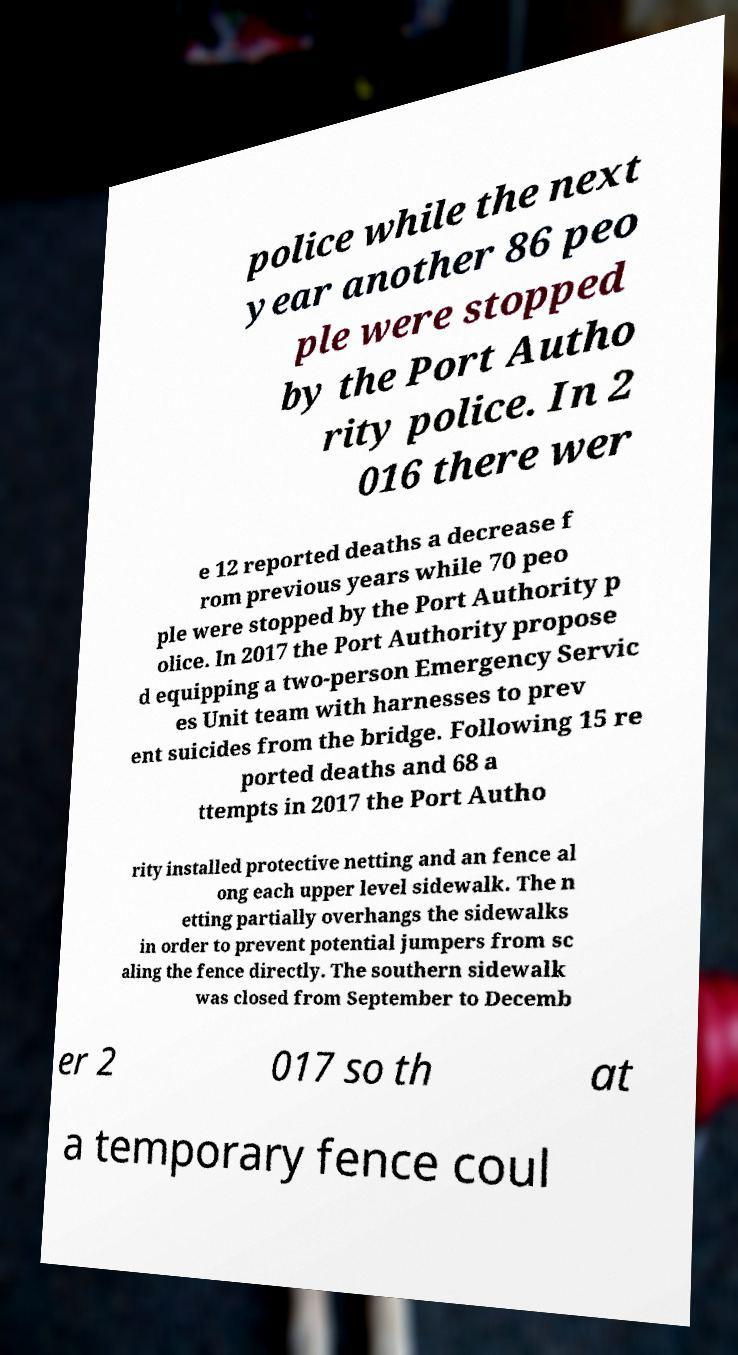What messages or text are displayed in this image? I need them in a readable, typed format. police while the next year another 86 peo ple were stopped by the Port Autho rity police. In 2 016 there wer e 12 reported deaths a decrease f rom previous years while 70 peo ple were stopped by the Port Authority p olice. In 2017 the Port Authority propose d equipping a two-person Emergency Servic es Unit team with harnesses to prev ent suicides from the bridge. Following 15 re ported deaths and 68 a ttempts in 2017 the Port Autho rity installed protective netting and an fence al ong each upper level sidewalk. The n etting partially overhangs the sidewalks in order to prevent potential jumpers from sc aling the fence directly. The southern sidewalk was closed from September to Decemb er 2 017 so th at a temporary fence coul 